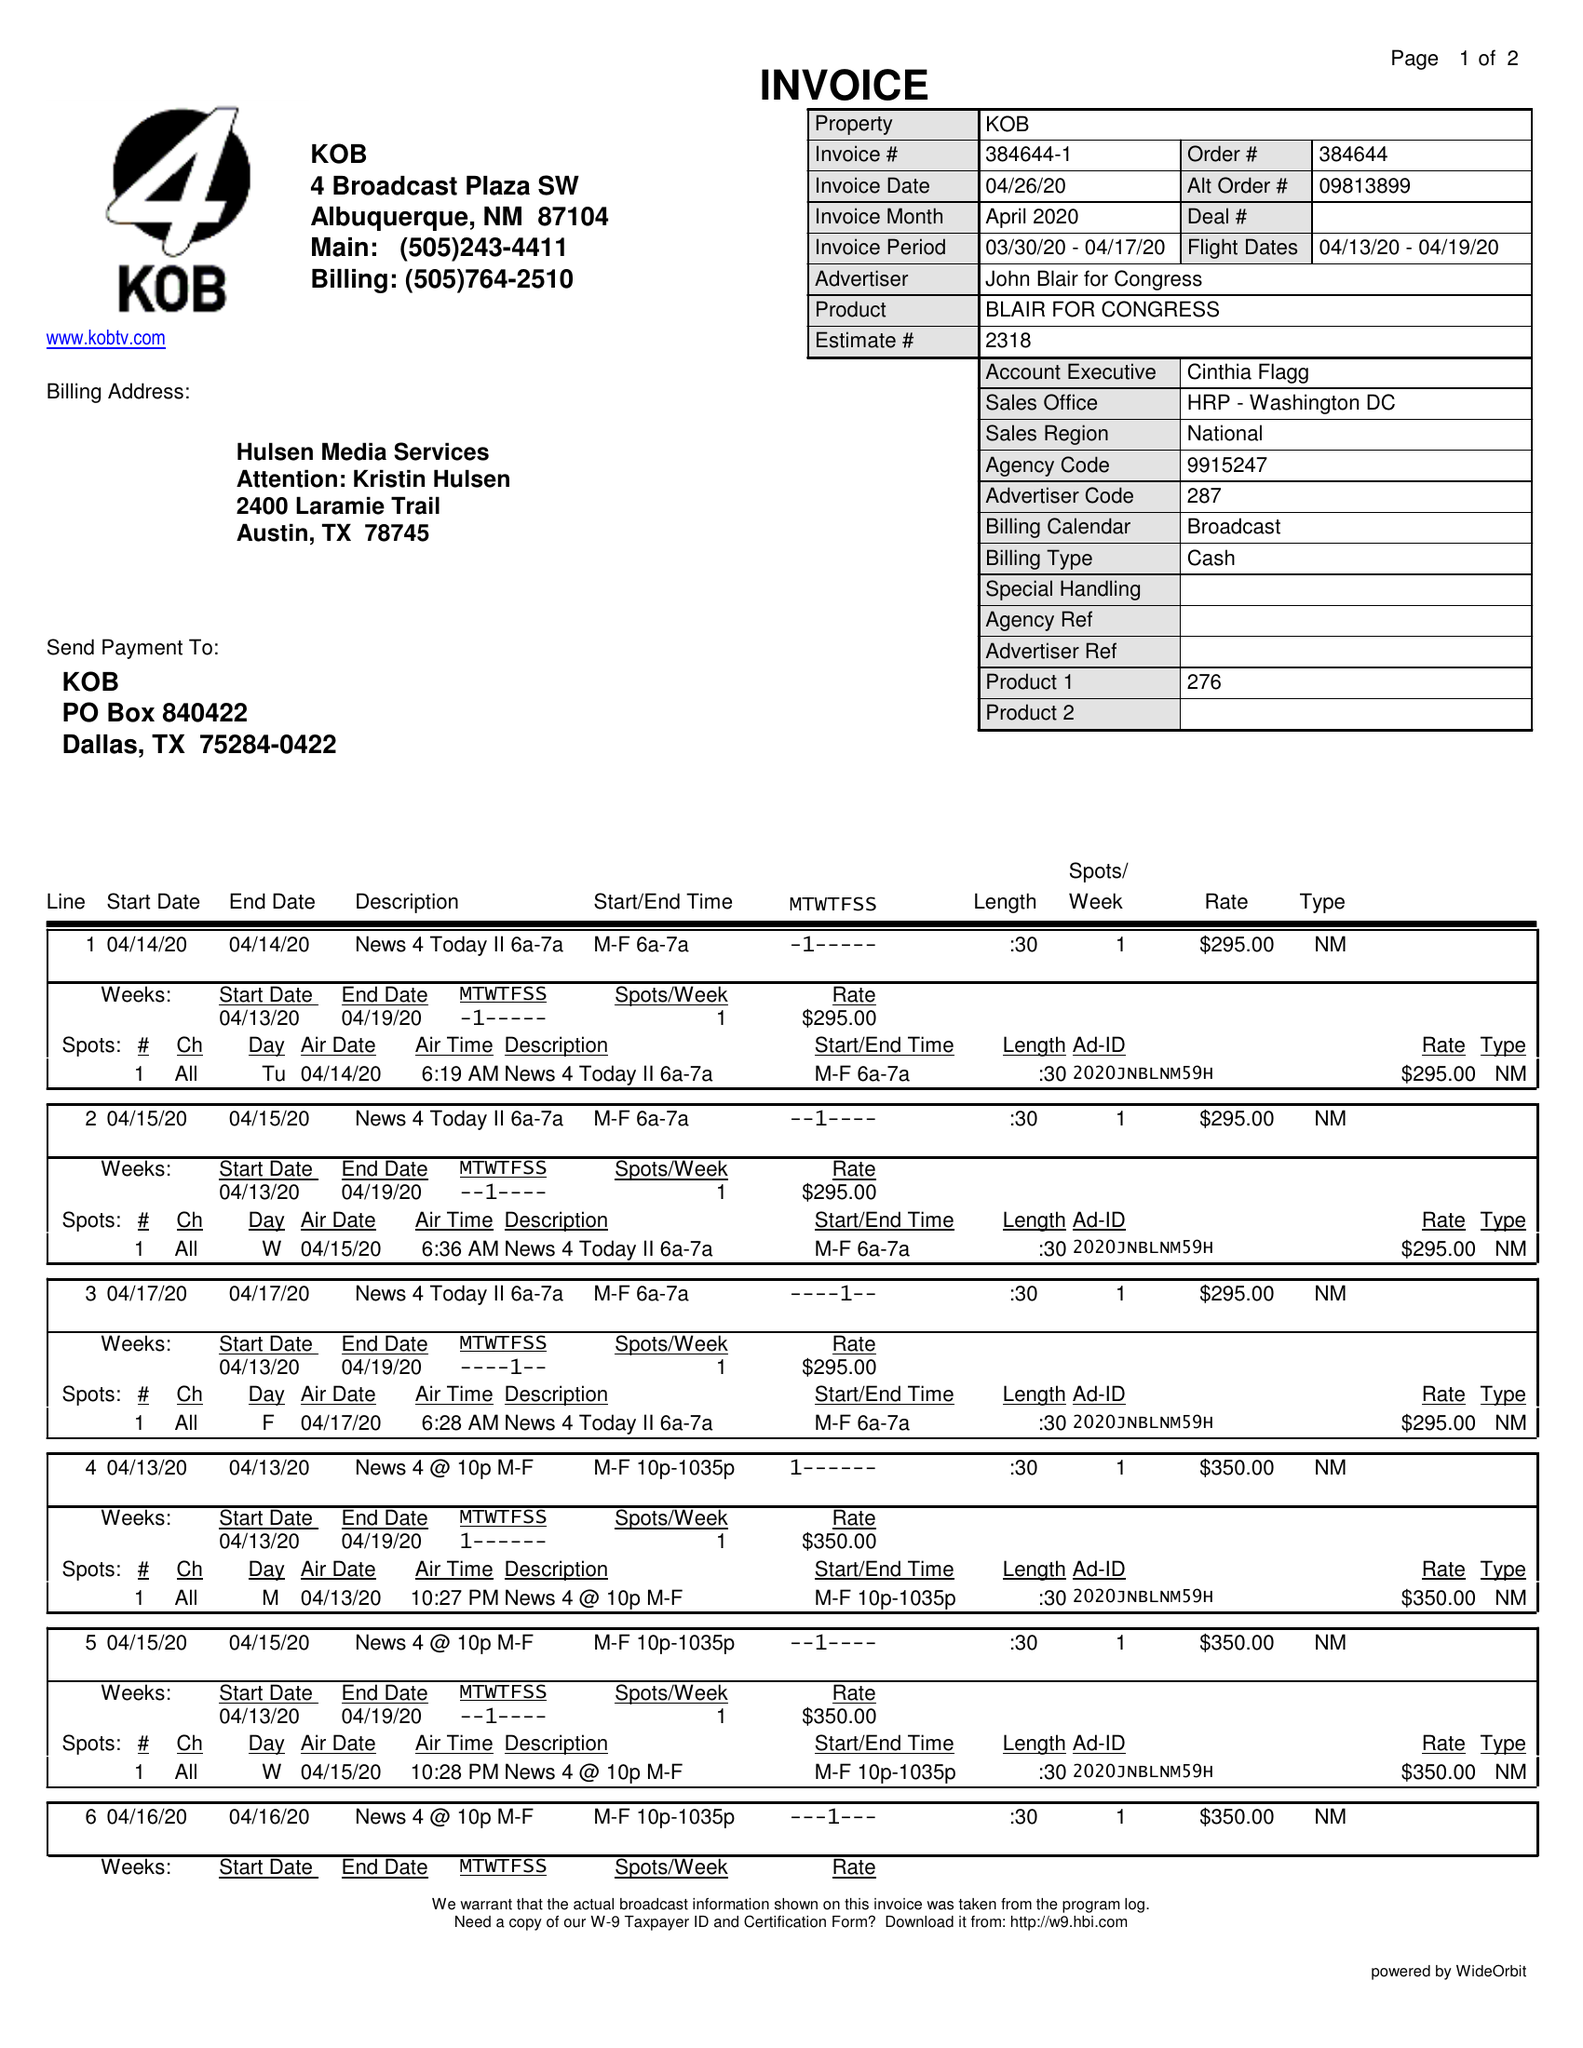What is the value for the gross_amount?
Answer the question using a single word or phrase. 2635.00 